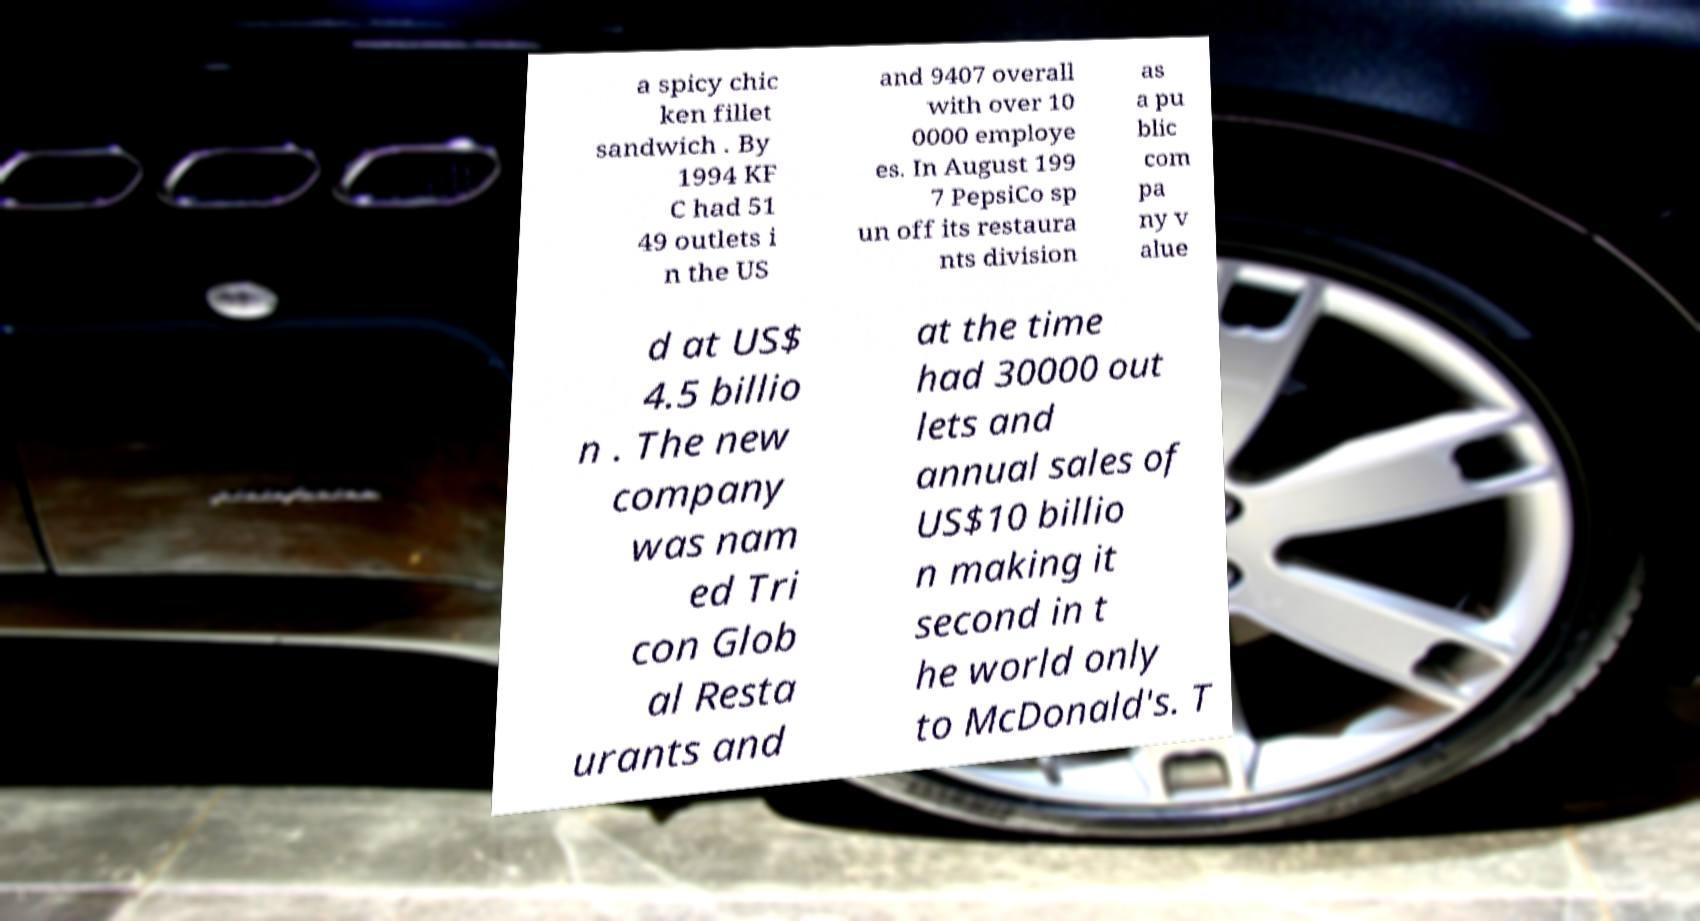Can you accurately transcribe the text from the provided image for me? a spicy chic ken fillet sandwich . By 1994 KF C had 51 49 outlets i n the US and 9407 overall with over 10 0000 employe es. In August 199 7 PepsiCo sp un off its restaura nts division as a pu blic com pa ny v alue d at US$ 4.5 billio n . The new company was nam ed Tri con Glob al Resta urants and at the time had 30000 out lets and annual sales of US$10 billio n making it second in t he world only to McDonald's. T 